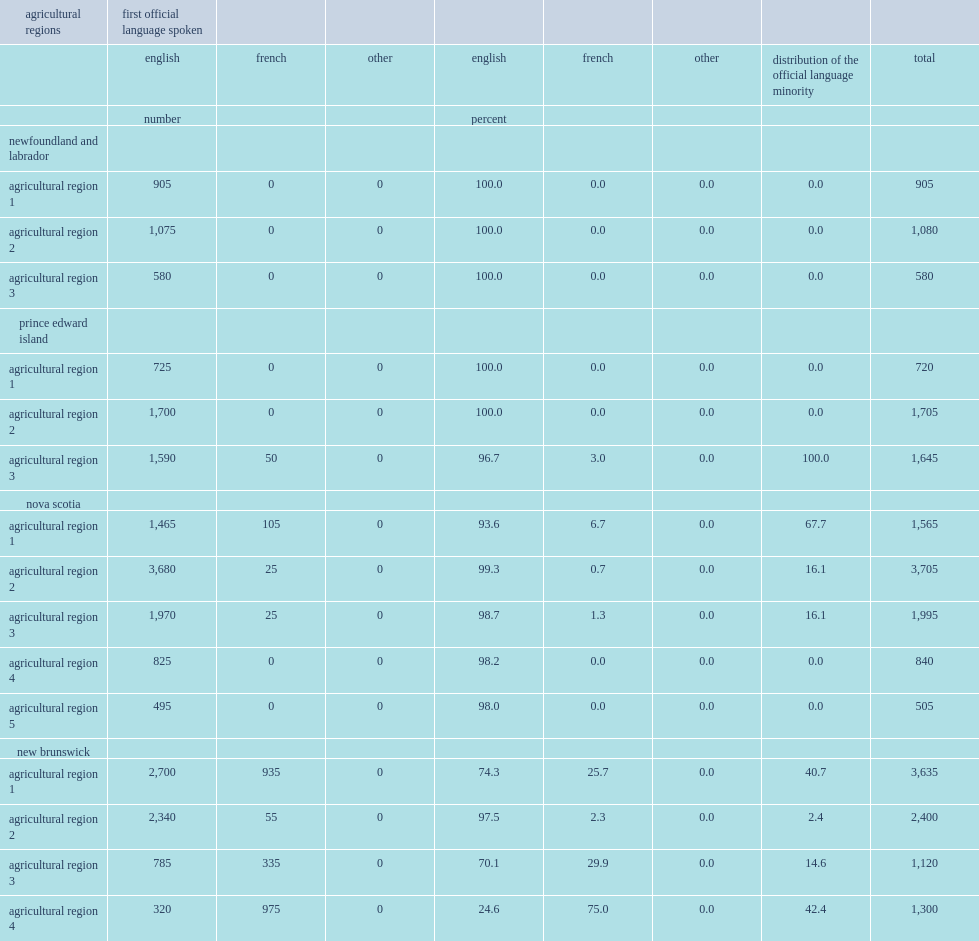How many workers aged 15 and over were in the atlantic canadian agricultural sector? 23700. What are the top two regions in the atlantic canadian agriculutral sector have more workers aged 15 and over ? New brunswick nova scotia. How many french-language agricultural workers were in the four atlantic provinces? 2505. How many french-language agricultural workers were in new brunswick alone? 2300. What is the percentage of the french-lanuage workers in new brunswick to all the atlantic provinces? 0.918164. How many percentage of agricultural workers in new brunswick was a french-language worker? 0.272028. 